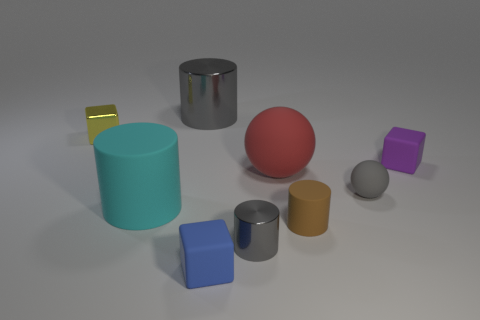Subtract all blocks. How many objects are left? 6 Add 2 big gray metal balls. How many big gray metal balls exist? 2 Subtract 2 gray cylinders. How many objects are left? 7 Subtract all large red spheres. Subtract all large metallic objects. How many objects are left? 7 Add 1 big cyan matte things. How many big cyan matte things are left? 2 